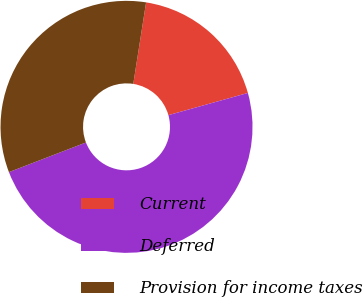<chart> <loc_0><loc_0><loc_500><loc_500><pie_chart><fcel>Current<fcel>Deferred<fcel>Provision for income taxes<nl><fcel>18.18%<fcel>48.48%<fcel>33.33%<nl></chart> 